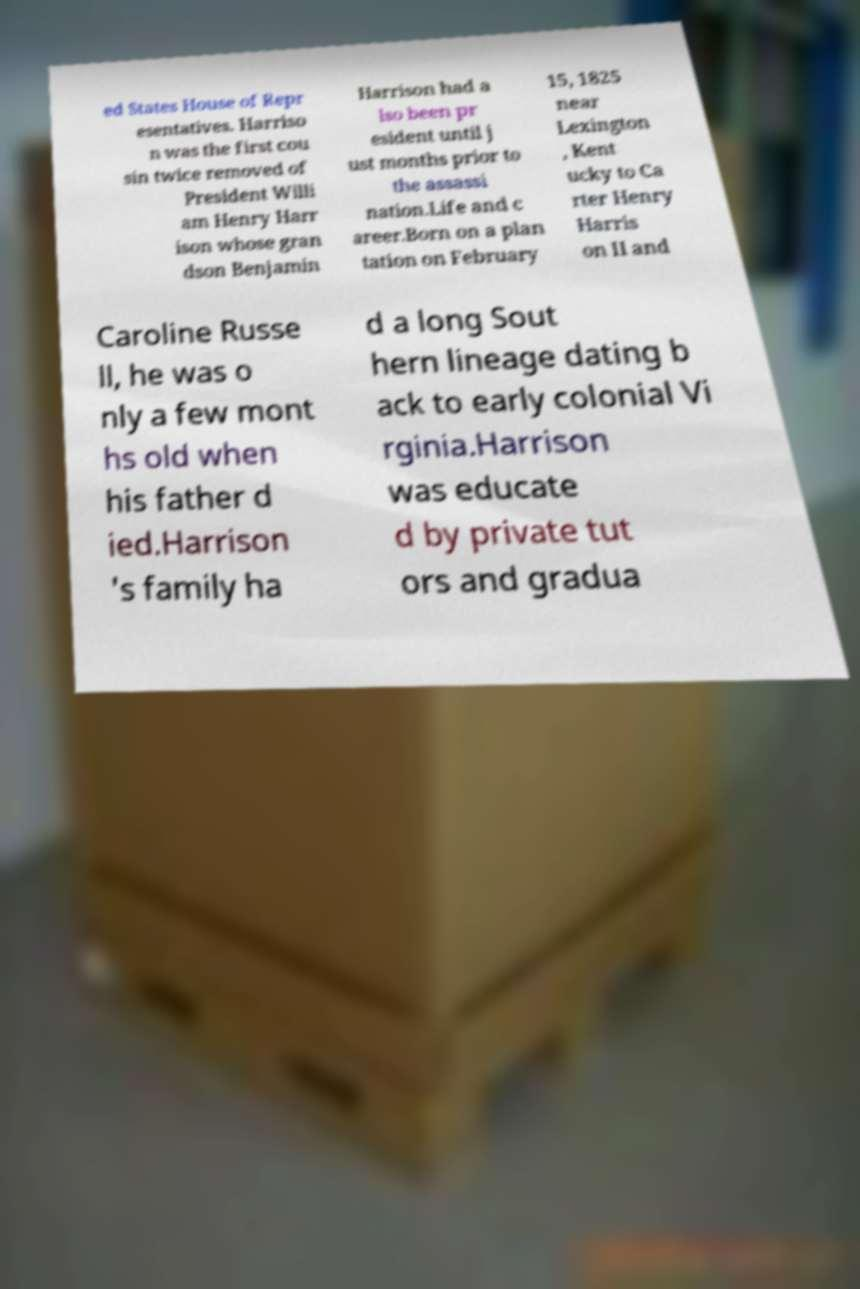Can you read and provide the text displayed in the image?This photo seems to have some interesting text. Can you extract and type it out for me? ed States House of Repr esentatives. Harriso n was the first cou sin twice removed of President Willi am Henry Harr ison whose gran dson Benjamin Harrison had a lso been pr esident until j ust months prior to the assassi nation.Life and c areer.Born on a plan tation on February 15, 1825 near Lexington , Kent ucky to Ca rter Henry Harris on II and Caroline Russe ll, he was o nly a few mont hs old when his father d ied.Harrison 's family ha d a long Sout hern lineage dating b ack to early colonial Vi rginia.Harrison was educate d by private tut ors and gradua 